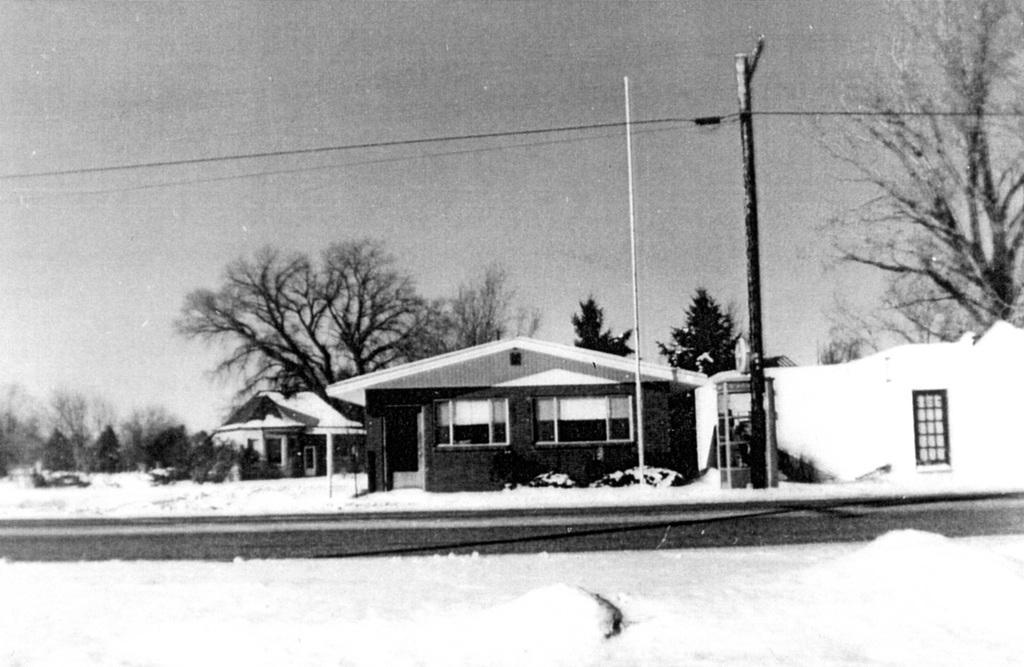In one or two sentences, can you explain what this image depicts? It is a black and white picture,there are few houses and around the houses there are some trees and the total land is covered with a lot of ice. 